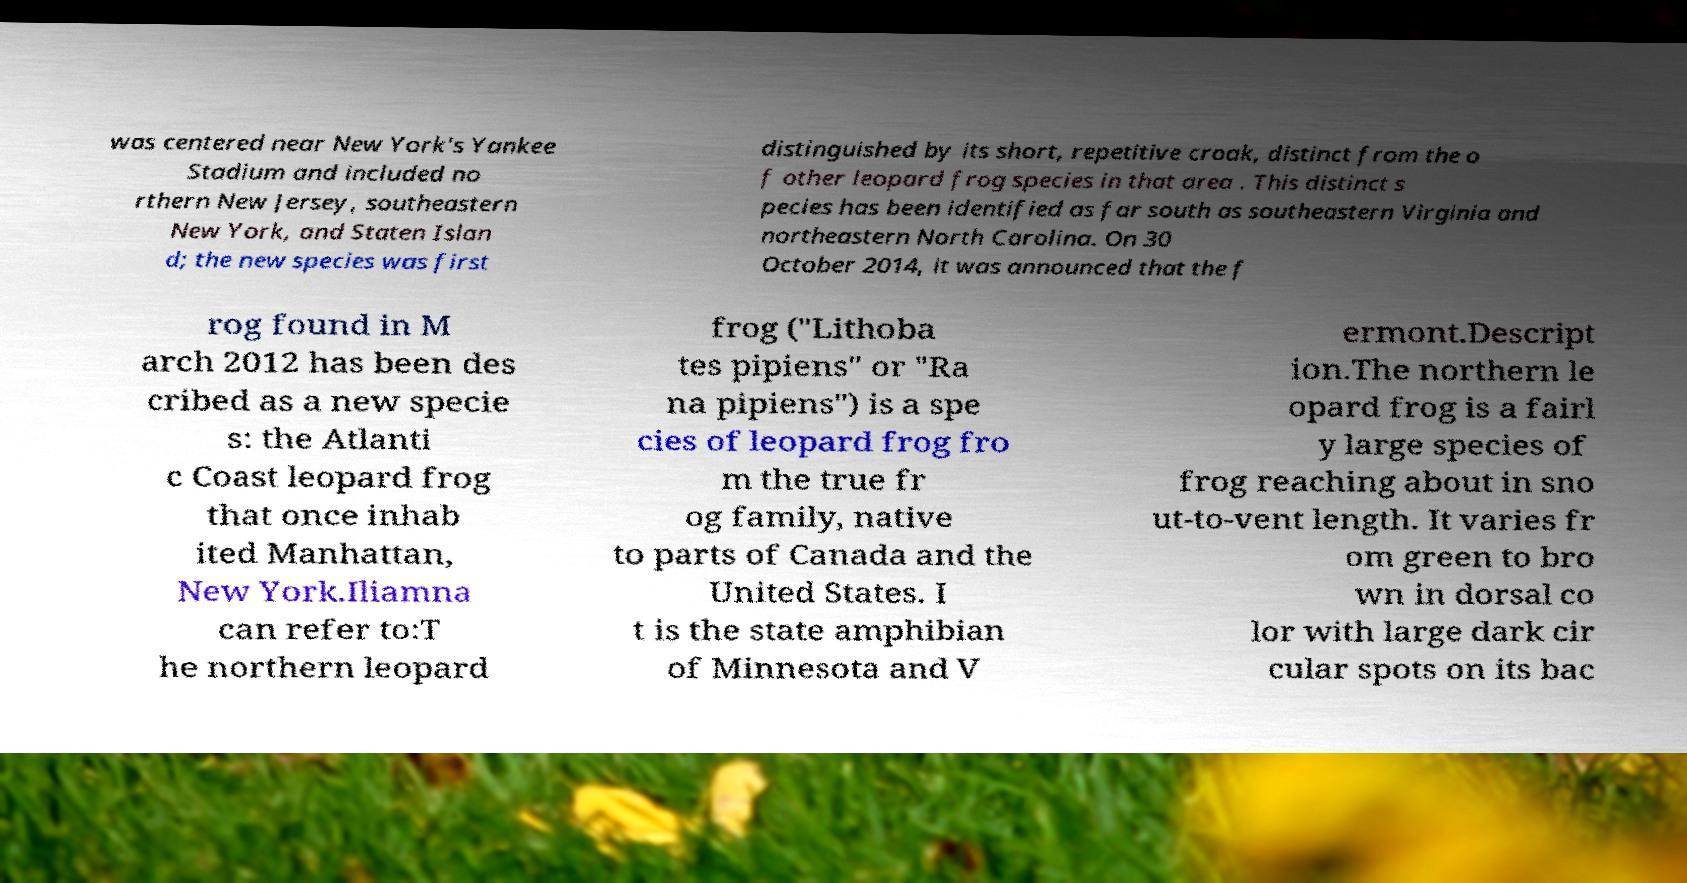Can you read and provide the text displayed in the image?This photo seems to have some interesting text. Can you extract and type it out for me? was centered near New York's Yankee Stadium and included no rthern New Jersey, southeastern New York, and Staten Islan d; the new species was first distinguished by its short, repetitive croak, distinct from the o f other leopard frog species in that area . This distinct s pecies has been identified as far south as southeastern Virginia and northeastern North Carolina. On 30 October 2014, it was announced that the f rog found in M arch 2012 has been des cribed as a new specie s: the Atlanti c Coast leopard frog that once inhab ited Manhattan, New York.Iliamna can refer to:T he northern leopard frog ("Lithoba tes pipiens" or "Ra na pipiens") is a spe cies of leopard frog fro m the true fr og family, native to parts of Canada and the United States. I t is the state amphibian of Minnesota and V ermont.Descript ion.The northern le opard frog is a fairl y large species of frog reaching about in sno ut-to-vent length. It varies fr om green to bro wn in dorsal co lor with large dark cir cular spots on its bac 